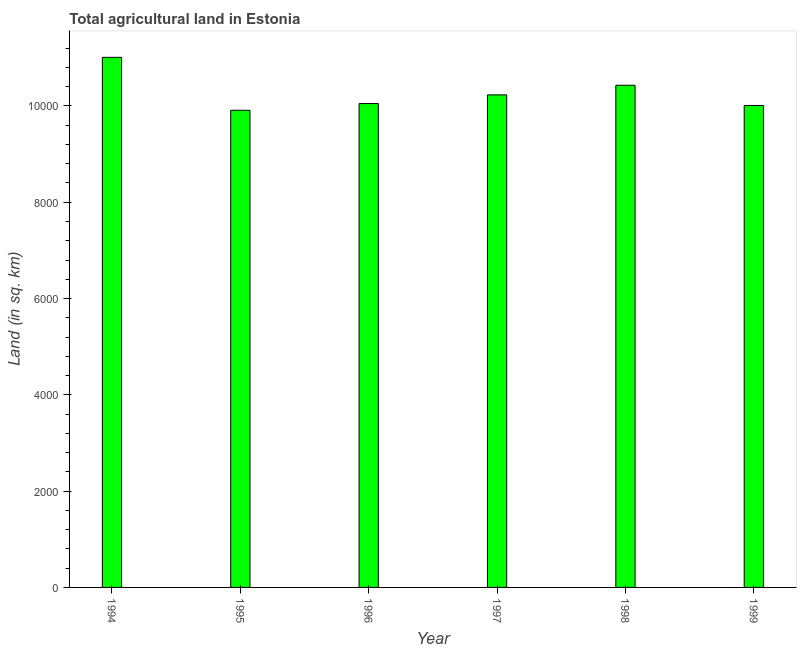Does the graph contain any zero values?
Ensure brevity in your answer.  No. What is the title of the graph?
Provide a short and direct response. Total agricultural land in Estonia. What is the label or title of the Y-axis?
Your response must be concise. Land (in sq. km). What is the agricultural land in 1998?
Offer a very short reply. 1.04e+04. Across all years, what is the maximum agricultural land?
Your answer should be compact. 1.10e+04. Across all years, what is the minimum agricultural land?
Your response must be concise. 9910. In which year was the agricultural land maximum?
Make the answer very short. 1994. In which year was the agricultural land minimum?
Provide a short and direct response. 1995. What is the sum of the agricultural land?
Give a very brief answer. 6.16e+04. What is the difference between the agricultural land in 1997 and 1998?
Offer a terse response. -200. What is the average agricultural land per year?
Your answer should be very brief. 1.03e+04. What is the median agricultural land?
Make the answer very short. 1.01e+04. In how many years, is the agricultural land greater than 4800 sq. km?
Offer a very short reply. 6. What is the ratio of the agricultural land in 1994 to that in 1997?
Ensure brevity in your answer.  1.08. Is the agricultural land in 1995 less than that in 1999?
Give a very brief answer. Yes. What is the difference between the highest and the second highest agricultural land?
Provide a short and direct response. 580. What is the difference between the highest and the lowest agricultural land?
Give a very brief answer. 1100. In how many years, is the agricultural land greater than the average agricultural land taken over all years?
Your answer should be compact. 2. What is the difference between two consecutive major ticks on the Y-axis?
Give a very brief answer. 2000. Are the values on the major ticks of Y-axis written in scientific E-notation?
Provide a short and direct response. No. What is the Land (in sq. km) of 1994?
Your answer should be very brief. 1.10e+04. What is the Land (in sq. km) of 1995?
Your response must be concise. 9910. What is the Land (in sq. km) in 1996?
Offer a terse response. 1.00e+04. What is the Land (in sq. km) in 1997?
Provide a short and direct response. 1.02e+04. What is the Land (in sq. km) in 1998?
Ensure brevity in your answer.  1.04e+04. What is the Land (in sq. km) in 1999?
Provide a short and direct response. 1.00e+04. What is the difference between the Land (in sq. km) in 1994 and 1995?
Give a very brief answer. 1100. What is the difference between the Land (in sq. km) in 1994 and 1996?
Give a very brief answer. 960. What is the difference between the Land (in sq. km) in 1994 and 1997?
Provide a succinct answer. 780. What is the difference between the Land (in sq. km) in 1994 and 1998?
Give a very brief answer. 580. What is the difference between the Land (in sq. km) in 1995 and 1996?
Your answer should be compact. -140. What is the difference between the Land (in sq. km) in 1995 and 1997?
Your answer should be very brief. -320. What is the difference between the Land (in sq. km) in 1995 and 1998?
Keep it short and to the point. -520. What is the difference between the Land (in sq. km) in 1995 and 1999?
Offer a terse response. -100. What is the difference between the Land (in sq. km) in 1996 and 1997?
Your answer should be very brief. -180. What is the difference between the Land (in sq. km) in 1996 and 1998?
Your answer should be very brief. -380. What is the difference between the Land (in sq. km) in 1996 and 1999?
Your answer should be very brief. 40. What is the difference between the Land (in sq. km) in 1997 and 1998?
Your answer should be compact. -200. What is the difference between the Land (in sq. km) in 1997 and 1999?
Your response must be concise. 220. What is the difference between the Land (in sq. km) in 1998 and 1999?
Make the answer very short. 420. What is the ratio of the Land (in sq. km) in 1994 to that in 1995?
Make the answer very short. 1.11. What is the ratio of the Land (in sq. km) in 1994 to that in 1996?
Your answer should be very brief. 1.1. What is the ratio of the Land (in sq. km) in 1994 to that in 1997?
Give a very brief answer. 1.08. What is the ratio of the Land (in sq. km) in 1994 to that in 1998?
Ensure brevity in your answer.  1.06. What is the ratio of the Land (in sq. km) in 1995 to that in 1997?
Your response must be concise. 0.97. What is the ratio of the Land (in sq. km) in 1996 to that in 1997?
Your answer should be compact. 0.98. What is the ratio of the Land (in sq. km) in 1996 to that in 1999?
Offer a terse response. 1. What is the ratio of the Land (in sq. km) in 1997 to that in 1998?
Offer a terse response. 0.98. What is the ratio of the Land (in sq. km) in 1998 to that in 1999?
Your answer should be very brief. 1.04. 